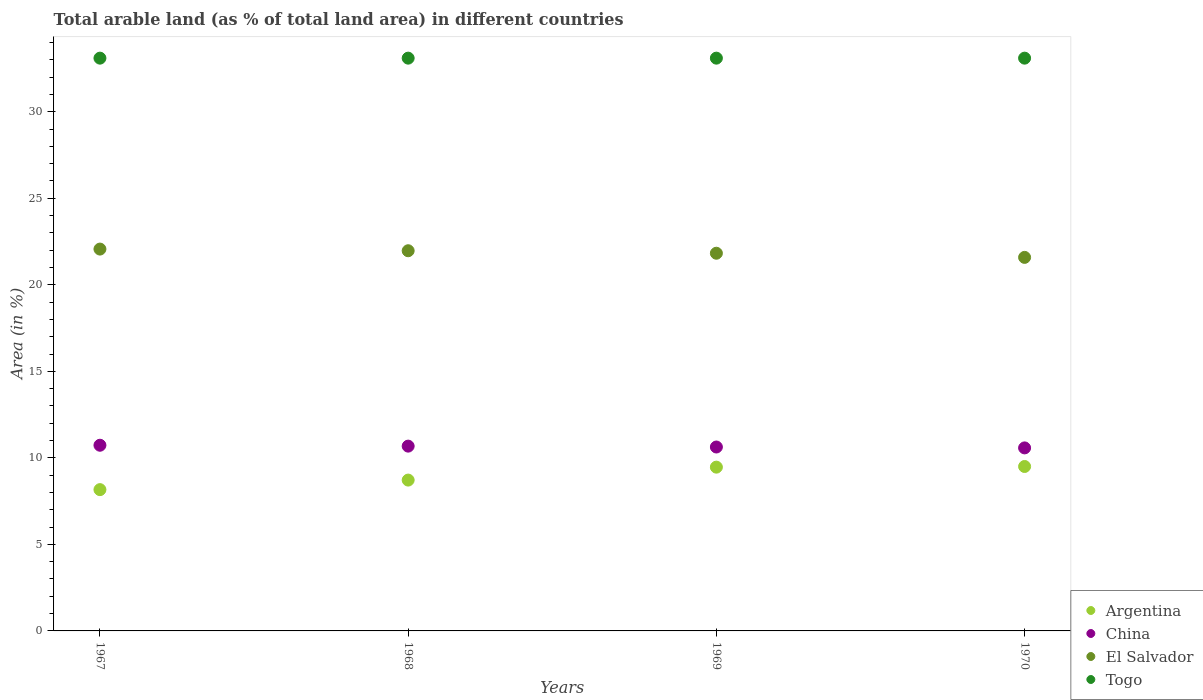How many different coloured dotlines are there?
Your answer should be compact. 4. What is the percentage of arable land in Argentina in 1969?
Your answer should be very brief. 9.46. Across all years, what is the maximum percentage of arable land in China?
Provide a short and direct response. 10.73. Across all years, what is the minimum percentage of arable land in Argentina?
Ensure brevity in your answer.  8.16. In which year was the percentage of arable land in Argentina minimum?
Provide a short and direct response. 1967. What is the total percentage of arable land in El Salvador in the graph?
Offer a very short reply. 87.43. What is the difference between the percentage of arable land in Argentina in 1969 and that in 1970?
Ensure brevity in your answer.  -0.04. What is the difference between the percentage of arable land in Togo in 1967 and the percentage of arable land in Argentina in 1970?
Provide a succinct answer. 23.59. What is the average percentage of arable land in China per year?
Make the answer very short. 10.65. In the year 1970, what is the difference between the percentage of arable land in El Salvador and percentage of arable land in Argentina?
Offer a terse response. 12.08. What is the ratio of the percentage of arable land in China in 1967 to that in 1969?
Keep it short and to the point. 1.01. Is the difference between the percentage of arable land in El Salvador in 1967 and 1970 greater than the difference between the percentage of arable land in Argentina in 1967 and 1970?
Provide a succinct answer. Yes. What is the difference between the highest and the second highest percentage of arable land in El Salvador?
Provide a succinct answer. 0.1. What is the difference between the highest and the lowest percentage of arable land in El Salvador?
Keep it short and to the point. 0.48. In how many years, is the percentage of arable land in El Salvador greater than the average percentage of arable land in El Salvador taken over all years?
Provide a short and direct response. 2. Is the percentage of arable land in China strictly less than the percentage of arable land in Argentina over the years?
Provide a succinct answer. No. How many dotlines are there?
Give a very brief answer. 4. How many years are there in the graph?
Give a very brief answer. 4. What is the difference between two consecutive major ticks on the Y-axis?
Offer a very short reply. 5. How many legend labels are there?
Your answer should be very brief. 4. How are the legend labels stacked?
Keep it short and to the point. Vertical. What is the title of the graph?
Your response must be concise. Total arable land (as % of total land area) in different countries. Does "Mexico" appear as one of the legend labels in the graph?
Make the answer very short. No. What is the label or title of the X-axis?
Ensure brevity in your answer.  Years. What is the label or title of the Y-axis?
Offer a very short reply. Area (in %). What is the Area (in %) in Argentina in 1967?
Keep it short and to the point. 8.16. What is the Area (in %) of China in 1967?
Offer a very short reply. 10.73. What is the Area (in %) of El Salvador in 1967?
Your answer should be very brief. 22.06. What is the Area (in %) in Togo in 1967?
Your response must be concise. 33.09. What is the Area (in %) of Argentina in 1968?
Your response must be concise. 8.72. What is the Area (in %) in China in 1968?
Offer a very short reply. 10.68. What is the Area (in %) in El Salvador in 1968?
Provide a short and direct response. 21.97. What is the Area (in %) of Togo in 1968?
Your response must be concise. 33.09. What is the Area (in %) of Argentina in 1969?
Your answer should be very brief. 9.46. What is the Area (in %) in China in 1969?
Make the answer very short. 10.63. What is the Area (in %) in El Salvador in 1969?
Provide a succinct answer. 21.82. What is the Area (in %) in Togo in 1969?
Your response must be concise. 33.09. What is the Area (in %) of Argentina in 1970?
Your answer should be very brief. 9.5. What is the Area (in %) of China in 1970?
Keep it short and to the point. 10.57. What is the Area (in %) in El Salvador in 1970?
Ensure brevity in your answer.  21.58. What is the Area (in %) of Togo in 1970?
Give a very brief answer. 33.09. Across all years, what is the maximum Area (in %) in Argentina?
Keep it short and to the point. 9.5. Across all years, what is the maximum Area (in %) in China?
Keep it short and to the point. 10.73. Across all years, what is the maximum Area (in %) of El Salvador?
Provide a succinct answer. 22.06. Across all years, what is the maximum Area (in %) of Togo?
Your answer should be very brief. 33.09. Across all years, what is the minimum Area (in %) of Argentina?
Provide a succinct answer. 8.16. Across all years, what is the minimum Area (in %) in China?
Make the answer very short. 10.57. Across all years, what is the minimum Area (in %) of El Salvador?
Your response must be concise. 21.58. Across all years, what is the minimum Area (in %) of Togo?
Offer a terse response. 33.09. What is the total Area (in %) in Argentina in the graph?
Make the answer very short. 35.84. What is the total Area (in %) in China in the graph?
Your answer should be very brief. 42.61. What is the total Area (in %) of El Salvador in the graph?
Your answer should be very brief. 87.43. What is the total Area (in %) of Togo in the graph?
Ensure brevity in your answer.  132.38. What is the difference between the Area (in %) in Argentina in 1967 and that in 1968?
Give a very brief answer. -0.55. What is the difference between the Area (in %) in China in 1967 and that in 1968?
Offer a very short reply. 0.05. What is the difference between the Area (in %) of El Salvador in 1967 and that in 1968?
Your response must be concise. 0.1. What is the difference between the Area (in %) in Togo in 1967 and that in 1968?
Offer a very short reply. 0. What is the difference between the Area (in %) of Argentina in 1967 and that in 1969?
Offer a terse response. -1.3. What is the difference between the Area (in %) of China in 1967 and that in 1969?
Provide a succinct answer. 0.1. What is the difference between the Area (in %) of El Salvador in 1967 and that in 1969?
Provide a succinct answer. 0.24. What is the difference between the Area (in %) in Argentina in 1967 and that in 1970?
Your answer should be very brief. -1.34. What is the difference between the Area (in %) in China in 1967 and that in 1970?
Offer a very short reply. 0.15. What is the difference between the Area (in %) in El Salvador in 1967 and that in 1970?
Make the answer very short. 0.48. What is the difference between the Area (in %) in Argentina in 1968 and that in 1969?
Offer a terse response. -0.75. What is the difference between the Area (in %) in China in 1968 and that in 1969?
Provide a succinct answer. 0.05. What is the difference between the Area (in %) of El Salvador in 1968 and that in 1969?
Provide a succinct answer. 0.14. What is the difference between the Area (in %) in Togo in 1968 and that in 1969?
Provide a succinct answer. 0. What is the difference between the Area (in %) of Argentina in 1968 and that in 1970?
Offer a terse response. -0.79. What is the difference between the Area (in %) of China in 1968 and that in 1970?
Give a very brief answer. 0.1. What is the difference between the Area (in %) in El Salvador in 1968 and that in 1970?
Offer a terse response. 0.38. What is the difference between the Area (in %) in Togo in 1968 and that in 1970?
Your answer should be compact. 0. What is the difference between the Area (in %) of Argentina in 1969 and that in 1970?
Give a very brief answer. -0.04. What is the difference between the Area (in %) in China in 1969 and that in 1970?
Offer a terse response. 0.05. What is the difference between the Area (in %) of El Salvador in 1969 and that in 1970?
Your answer should be compact. 0.24. What is the difference between the Area (in %) in Argentina in 1967 and the Area (in %) in China in 1968?
Offer a terse response. -2.51. What is the difference between the Area (in %) in Argentina in 1967 and the Area (in %) in El Salvador in 1968?
Your answer should be compact. -13.8. What is the difference between the Area (in %) in Argentina in 1967 and the Area (in %) in Togo in 1968?
Your answer should be compact. -24.93. What is the difference between the Area (in %) in China in 1967 and the Area (in %) in El Salvador in 1968?
Offer a terse response. -11.24. What is the difference between the Area (in %) in China in 1967 and the Area (in %) in Togo in 1968?
Provide a succinct answer. -22.37. What is the difference between the Area (in %) of El Salvador in 1967 and the Area (in %) of Togo in 1968?
Ensure brevity in your answer.  -11.03. What is the difference between the Area (in %) in Argentina in 1967 and the Area (in %) in China in 1969?
Your response must be concise. -2.46. What is the difference between the Area (in %) of Argentina in 1967 and the Area (in %) of El Salvador in 1969?
Provide a succinct answer. -13.66. What is the difference between the Area (in %) in Argentina in 1967 and the Area (in %) in Togo in 1969?
Your answer should be compact. -24.93. What is the difference between the Area (in %) of China in 1967 and the Area (in %) of El Salvador in 1969?
Your answer should be compact. -11.09. What is the difference between the Area (in %) of China in 1967 and the Area (in %) of Togo in 1969?
Your answer should be compact. -22.37. What is the difference between the Area (in %) of El Salvador in 1967 and the Area (in %) of Togo in 1969?
Offer a terse response. -11.03. What is the difference between the Area (in %) in Argentina in 1967 and the Area (in %) in China in 1970?
Provide a short and direct response. -2.41. What is the difference between the Area (in %) in Argentina in 1967 and the Area (in %) in El Salvador in 1970?
Offer a terse response. -13.42. What is the difference between the Area (in %) in Argentina in 1967 and the Area (in %) in Togo in 1970?
Provide a succinct answer. -24.93. What is the difference between the Area (in %) in China in 1967 and the Area (in %) in El Salvador in 1970?
Give a very brief answer. -10.85. What is the difference between the Area (in %) of China in 1967 and the Area (in %) of Togo in 1970?
Offer a very short reply. -22.37. What is the difference between the Area (in %) of El Salvador in 1967 and the Area (in %) of Togo in 1970?
Your response must be concise. -11.03. What is the difference between the Area (in %) in Argentina in 1968 and the Area (in %) in China in 1969?
Ensure brevity in your answer.  -1.91. What is the difference between the Area (in %) of Argentina in 1968 and the Area (in %) of El Salvador in 1969?
Your answer should be compact. -13.11. What is the difference between the Area (in %) in Argentina in 1968 and the Area (in %) in Togo in 1969?
Give a very brief answer. -24.38. What is the difference between the Area (in %) in China in 1968 and the Area (in %) in El Salvador in 1969?
Your response must be concise. -11.15. What is the difference between the Area (in %) of China in 1968 and the Area (in %) of Togo in 1969?
Your response must be concise. -22.42. What is the difference between the Area (in %) in El Salvador in 1968 and the Area (in %) in Togo in 1969?
Ensure brevity in your answer.  -11.13. What is the difference between the Area (in %) in Argentina in 1968 and the Area (in %) in China in 1970?
Ensure brevity in your answer.  -1.86. What is the difference between the Area (in %) of Argentina in 1968 and the Area (in %) of El Salvador in 1970?
Your answer should be compact. -12.87. What is the difference between the Area (in %) of Argentina in 1968 and the Area (in %) of Togo in 1970?
Provide a succinct answer. -24.38. What is the difference between the Area (in %) of China in 1968 and the Area (in %) of El Salvador in 1970?
Offer a very short reply. -10.91. What is the difference between the Area (in %) in China in 1968 and the Area (in %) in Togo in 1970?
Provide a succinct answer. -22.42. What is the difference between the Area (in %) of El Salvador in 1968 and the Area (in %) of Togo in 1970?
Make the answer very short. -11.13. What is the difference between the Area (in %) in Argentina in 1969 and the Area (in %) in China in 1970?
Give a very brief answer. -1.11. What is the difference between the Area (in %) of Argentina in 1969 and the Area (in %) of El Salvador in 1970?
Provide a succinct answer. -12.12. What is the difference between the Area (in %) in Argentina in 1969 and the Area (in %) in Togo in 1970?
Your response must be concise. -23.63. What is the difference between the Area (in %) of China in 1969 and the Area (in %) of El Salvador in 1970?
Keep it short and to the point. -10.96. What is the difference between the Area (in %) of China in 1969 and the Area (in %) of Togo in 1970?
Keep it short and to the point. -22.47. What is the difference between the Area (in %) of El Salvador in 1969 and the Area (in %) of Togo in 1970?
Give a very brief answer. -11.27. What is the average Area (in %) in Argentina per year?
Your answer should be compact. 8.96. What is the average Area (in %) of China per year?
Your answer should be very brief. 10.65. What is the average Area (in %) of El Salvador per year?
Ensure brevity in your answer.  21.86. What is the average Area (in %) of Togo per year?
Make the answer very short. 33.09. In the year 1967, what is the difference between the Area (in %) of Argentina and Area (in %) of China?
Provide a succinct answer. -2.56. In the year 1967, what is the difference between the Area (in %) in Argentina and Area (in %) in El Salvador?
Provide a short and direct response. -13.9. In the year 1967, what is the difference between the Area (in %) of Argentina and Area (in %) of Togo?
Provide a short and direct response. -24.93. In the year 1967, what is the difference between the Area (in %) of China and Area (in %) of El Salvador?
Provide a succinct answer. -11.33. In the year 1967, what is the difference between the Area (in %) in China and Area (in %) in Togo?
Give a very brief answer. -22.37. In the year 1967, what is the difference between the Area (in %) in El Salvador and Area (in %) in Togo?
Your answer should be compact. -11.03. In the year 1968, what is the difference between the Area (in %) of Argentina and Area (in %) of China?
Ensure brevity in your answer.  -1.96. In the year 1968, what is the difference between the Area (in %) in Argentina and Area (in %) in El Salvador?
Make the answer very short. -13.25. In the year 1968, what is the difference between the Area (in %) of Argentina and Area (in %) of Togo?
Provide a succinct answer. -24.38. In the year 1968, what is the difference between the Area (in %) in China and Area (in %) in El Salvador?
Your answer should be very brief. -11.29. In the year 1968, what is the difference between the Area (in %) in China and Area (in %) in Togo?
Make the answer very short. -22.42. In the year 1968, what is the difference between the Area (in %) of El Salvador and Area (in %) of Togo?
Keep it short and to the point. -11.13. In the year 1969, what is the difference between the Area (in %) of Argentina and Area (in %) of China?
Ensure brevity in your answer.  -1.16. In the year 1969, what is the difference between the Area (in %) of Argentina and Area (in %) of El Salvador?
Provide a succinct answer. -12.36. In the year 1969, what is the difference between the Area (in %) of Argentina and Area (in %) of Togo?
Ensure brevity in your answer.  -23.63. In the year 1969, what is the difference between the Area (in %) of China and Area (in %) of El Salvador?
Provide a succinct answer. -11.2. In the year 1969, what is the difference between the Area (in %) of China and Area (in %) of Togo?
Your answer should be compact. -22.47. In the year 1969, what is the difference between the Area (in %) of El Salvador and Area (in %) of Togo?
Make the answer very short. -11.27. In the year 1970, what is the difference between the Area (in %) in Argentina and Area (in %) in China?
Provide a short and direct response. -1.07. In the year 1970, what is the difference between the Area (in %) in Argentina and Area (in %) in El Salvador?
Give a very brief answer. -12.08. In the year 1970, what is the difference between the Area (in %) of Argentina and Area (in %) of Togo?
Ensure brevity in your answer.  -23.59. In the year 1970, what is the difference between the Area (in %) in China and Area (in %) in El Salvador?
Provide a succinct answer. -11.01. In the year 1970, what is the difference between the Area (in %) in China and Area (in %) in Togo?
Give a very brief answer. -22.52. In the year 1970, what is the difference between the Area (in %) in El Salvador and Area (in %) in Togo?
Provide a short and direct response. -11.51. What is the ratio of the Area (in %) of Argentina in 1967 to that in 1968?
Your answer should be compact. 0.94. What is the ratio of the Area (in %) in El Salvador in 1967 to that in 1968?
Make the answer very short. 1. What is the ratio of the Area (in %) of Togo in 1967 to that in 1968?
Provide a succinct answer. 1. What is the ratio of the Area (in %) in Argentina in 1967 to that in 1969?
Your response must be concise. 0.86. What is the ratio of the Area (in %) in China in 1967 to that in 1969?
Give a very brief answer. 1.01. What is the ratio of the Area (in %) in Togo in 1967 to that in 1969?
Offer a very short reply. 1. What is the ratio of the Area (in %) in Argentina in 1967 to that in 1970?
Provide a succinct answer. 0.86. What is the ratio of the Area (in %) of China in 1967 to that in 1970?
Your answer should be compact. 1.01. What is the ratio of the Area (in %) of El Salvador in 1967 to that in 1970?
Provide a succinct answer. 1.02. What is the ratio of the Area (in %) of Togo in 1967 to that in 1970?
Give a very brief answer. 1. What is the ratio of the Area (in %) of Argentina in 1968 to that in 1969?
Provide a short and direct response. 0.92. What is the ratio of the Area (in %) in China in 1968 to that in 1969?
Make the answer very short. 1. What is the ratio of the Area (in %) in El Salvador in 1968 to that in 1969?
Your answer should be very brief. 1.01. What is the ratio of the Area (in %) of Togo in 1968 to that in 1969?
Provide a short and direct response. 1. What is the ratio of the Area (in %) of Argentina in 1968 to that in 1970?
Make the answer very short. 0.92. What is the ratio of the Area (in %) in China in 1968 to that in 1970?
Your answer should be compact. 1.01. What is the ratio of the Area (in %) in El Salvador in 1968 to that in 1970?
Give a very brief answer. 1.02. What is the ratio of the Area (in %) in Togo in 1968 to that in 1970?
Ensure brevity in your answer.  1. What is the ratio of the Area (in %) in El Salvador in 1969 to that in 1970?
Provide a short and direct response. 1.01. What is the difference between the highest and the second highest Area (in %) in Argentina?
Your response must be concise. 0.04. What is the difference between the highest and the second highest Area (in %) in China?
Give a very brief answer. 0.05. What is the difference between the highest and the second highest Area (in %) of El Salvador?
Ensure brevity in your answer.  0.1. What is the difference between the highest and the second highest Area (in %) of Togo?
Ensure brevity in your answer.  0. What is the difference between the highest and the lowest Area (in %) of Argentina?
Offer a terse response. 1.34. What is the difference between the highest and the lowest Area (in %) of China?
Your answer should be very brief. 0.15. What is the difference between the highest and the lowest Area (in %) in El Salvador?
Keep it short and to the point. 0.48. What is the difference between the highest and the lowest Area (in %) in Togo?
Keep it short and to the point. 0. 